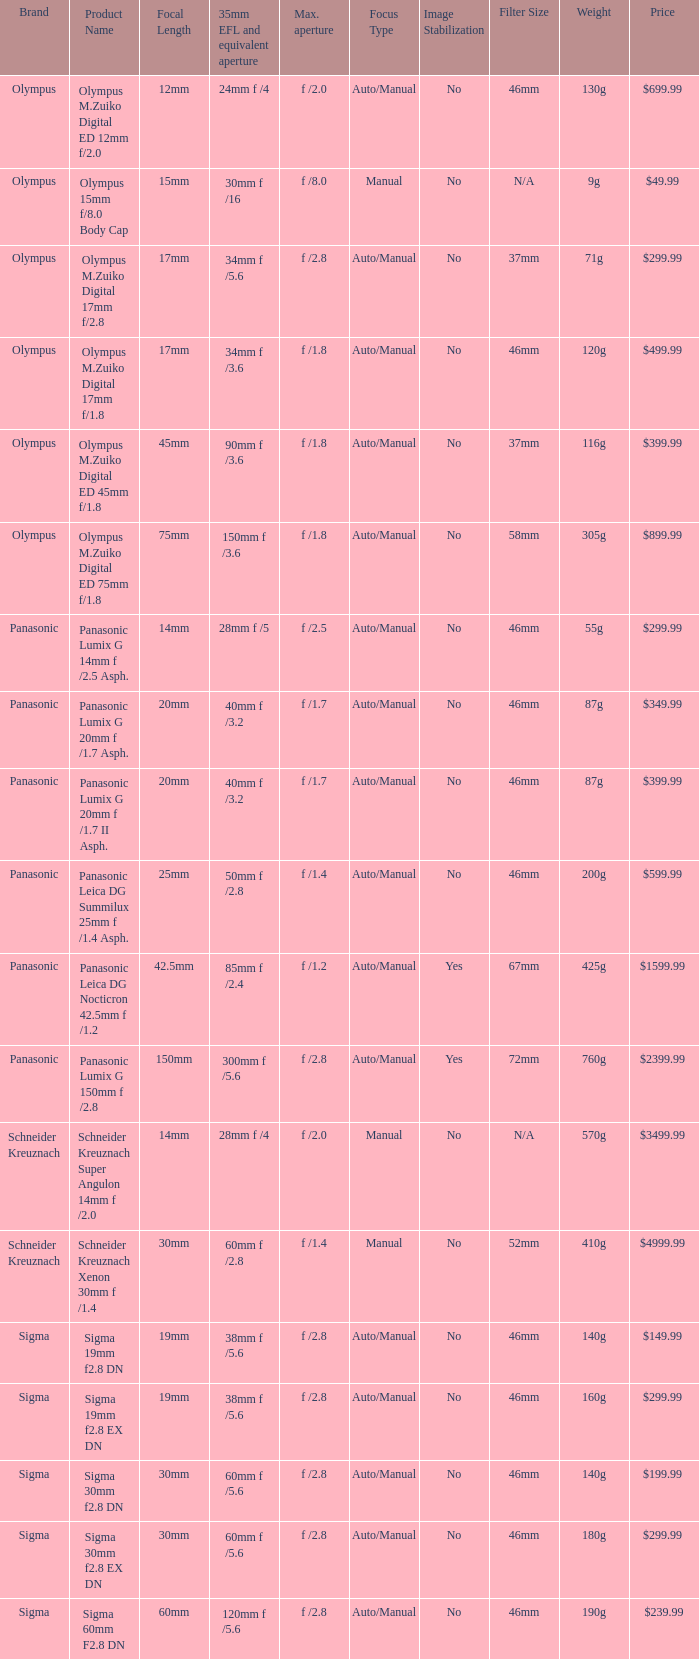What is the brand of the Sigma 30mm f2.8 DN, which has a maximum aperture of f /2.8 and a focal length of 30mm? Sigma. 